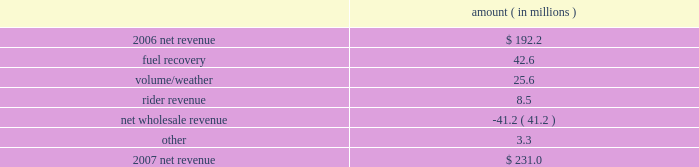Entergy new orleans , inc .
Management's financial discussion and analysis 2007 compared to 2006 net revenue consists of operating revenues net of : 1 ) fuel , fuel-related expenses , and gas purchased for resale , 2 ) purchased power expenses , and 3 ) other regulatory charges .
Following is an analysis of the change in net revenue comparing 2007 to 2006 .
Amount ( in millions ) .
The fuel recovery variance is due to the inclusion of grand gulf costs in fuel recoveries effective july 1 , 2006 .
In june 2006 , the city council approved the recovery of grand gulf costs through the fuel adjustment clause , without a corresponding change in base rates ( a significant portion of grand gulf costs was previously recovered through base rates ) .
The volume/weather variance is due to an increase in electricity usage in the service territory in 2007 compared to the same period in 2006 .
The first quarter 2006 was affected by customer losses following hurricane katrina .
Entergy new orleans estimates that approximately 132000 electric customers and 86000 gas customers have returned and are taking service as of december 31 , 2007 , compared to approximately 95000 electric customers and 65000 gas customers as of december 31 , 2006 .
Billed retail electricity usage increased a total of 540 gwh compared to the same period in 2006 , an increase of 14% ( 14 % ) .
The rider revenue variance is due primarily to a storm reserve rider effective march 2007 as a result of the city council's approval of a settlement agreement in october 2006 .
The approved storm reserve has been set to collect $ 75 million over a ten-year period through the rider and the funds will be held in a restricted escrow account .
The settlement agreement is discussed in note 2 to the financial statements .
The net wholesale revenue variance is due to more energy available for resale in 2006 due to the decrease in retail usage caused by customer losses following hurricane katrina .
In addition , 2006 revenue includes the sales into the wholesale market of entergy new orleans' share of the output of grand gulf , pursuant to city council approval of measures proposed by entergy new orleans to address the reduction in entergy new orleans' retail customer usage caused by hurricane katrina and to provide revenue support for the costs of entergy new orleans' share of grand other income statement variances 2008 compared to 2007 other operation and maintenance expenses decreased primarily due to : a provision for storm-related bad debts of $ 11 million recorded in 2007 ; a decrease of $ 6.2 million in legal and professional fees ; a decrease of $ 3.4 million in employee benefit expenses ; and a decrease of $ 1.9 million in gas operations spending due to higher labor and material costs for reliability work in 2007. .
What is the percentage change in the number of electric consumers from 2006 to 2007 for entergy new orleans? 
Computations: ((132000 - 95000) / 95000)
Answer: 0.38947. 